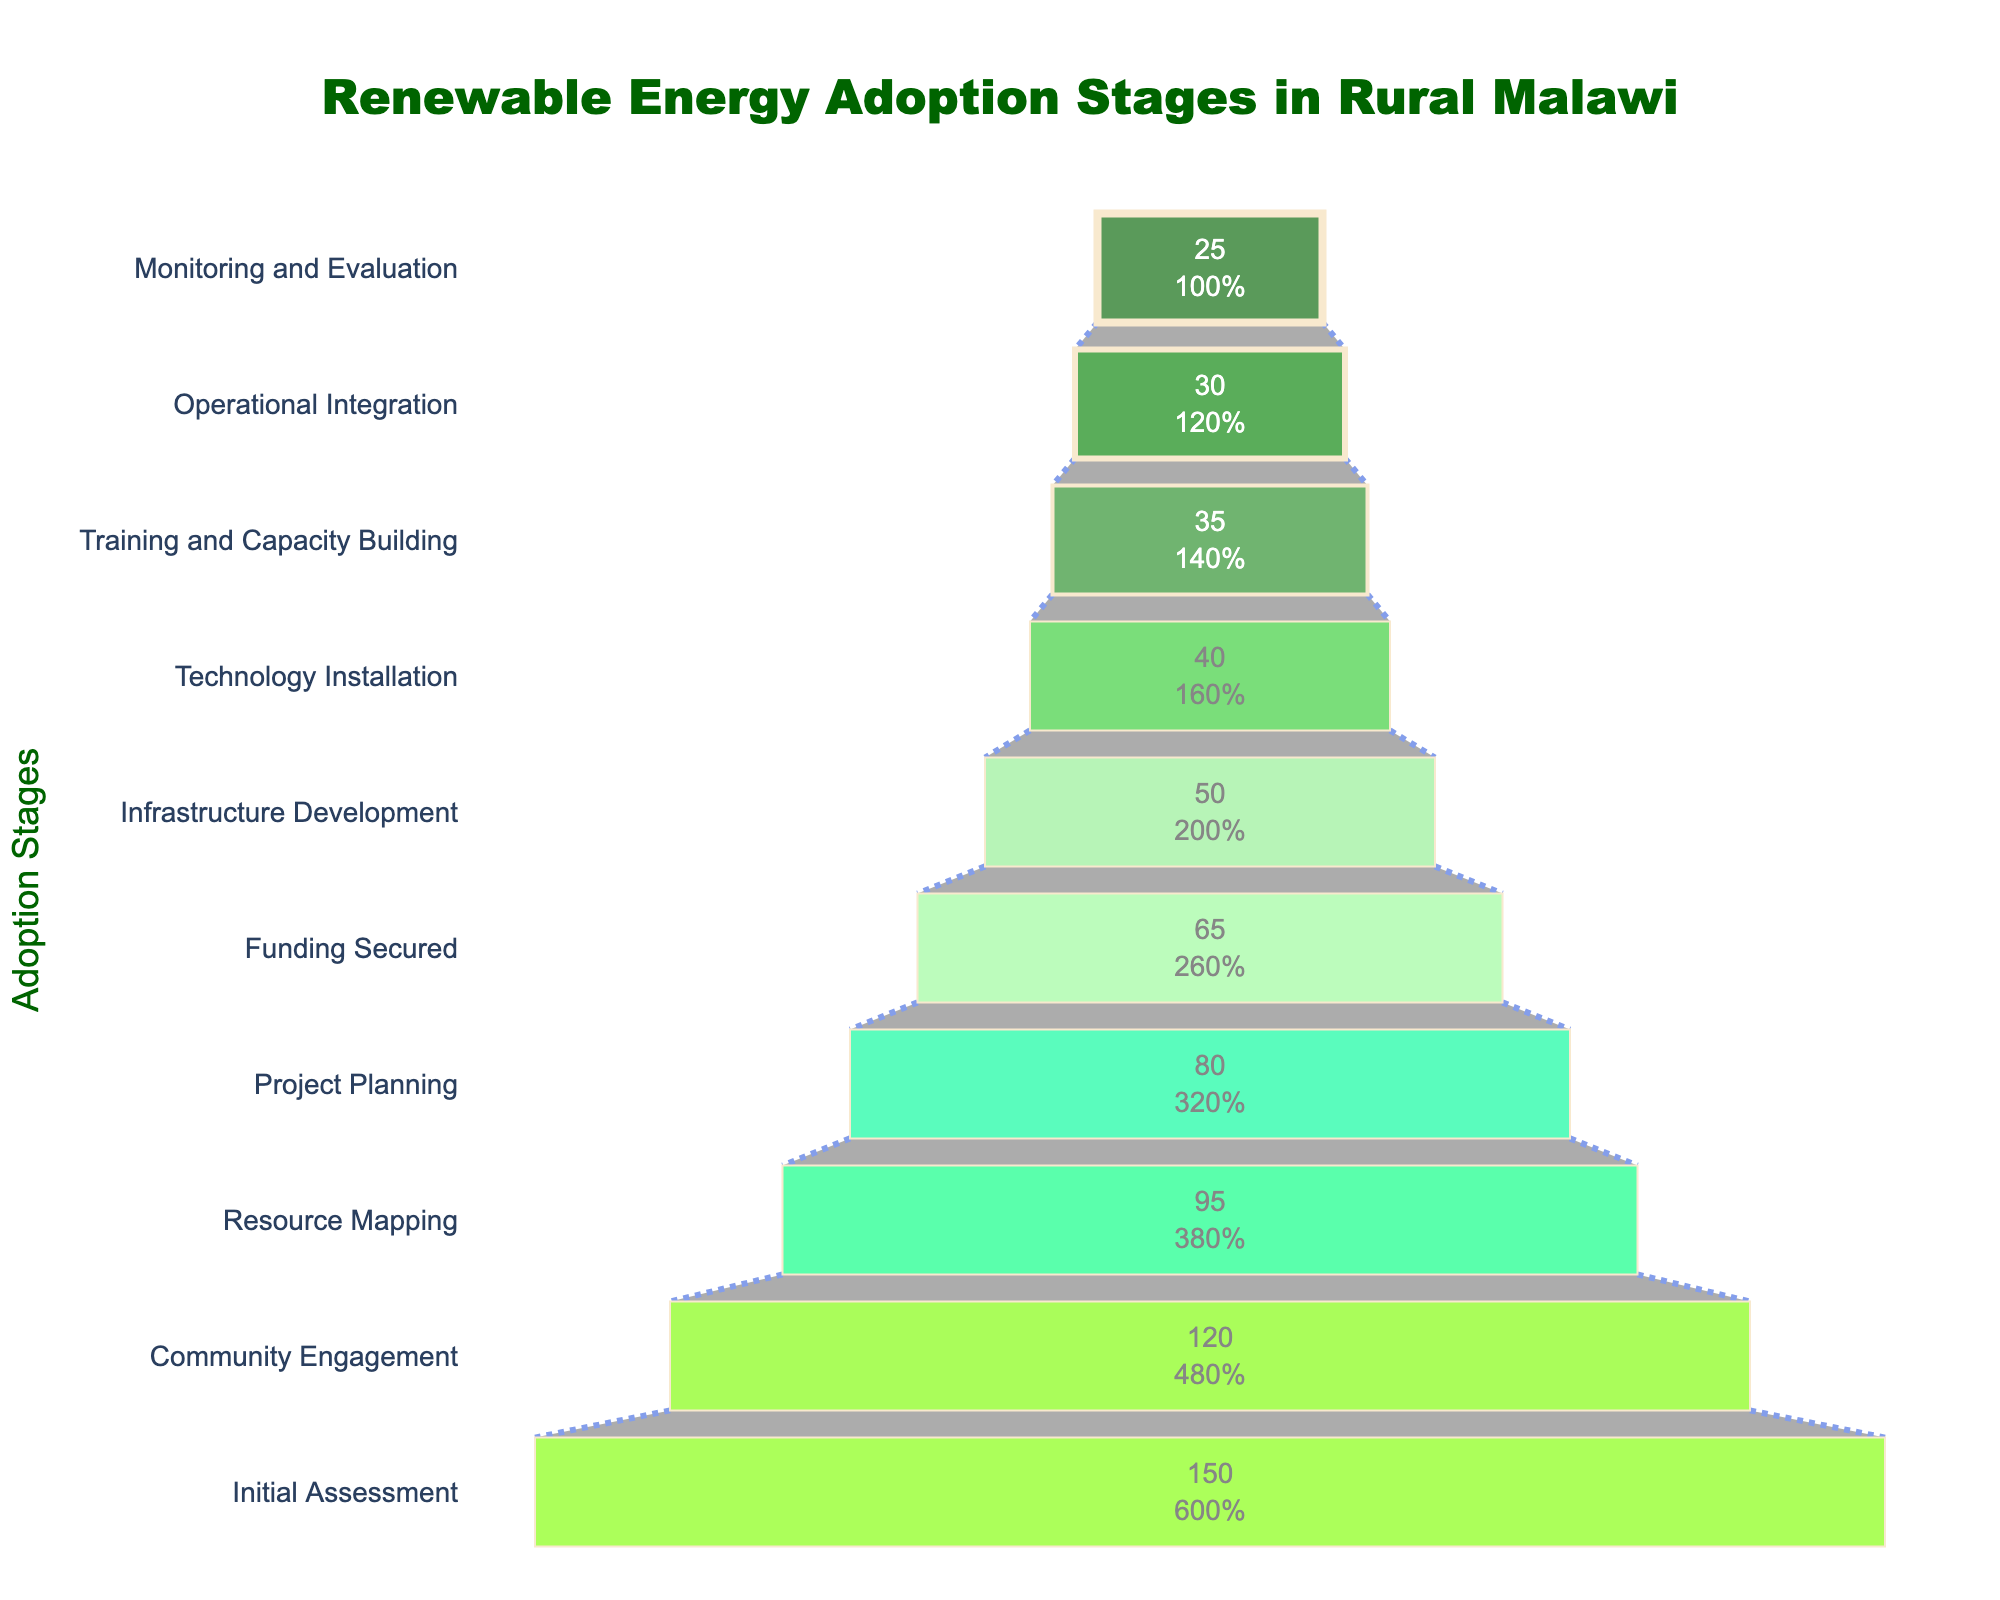What is the title of the funnel chart? The title is typically located at the top of the chart and summarizes the content or purpose of the chart.
Answer: Renewable Energy Adoption Stages in Rural Malawi How many stages are shown in the funnel chart? Count the unique stages listed on the y-axis of the chart.
Answer: 10 Which stage has the highest number of villages? The highest number of villages is represented by the widest bar at the top of the funnel. This corresponds to the first stage listed in the data.
Answer: Initial Assessment How many villages reach the 'Operational Integration' stage? Find the 'Operational Integration' stage on the y-axis and check the number of villages corresponding to that stage.
Answer: 30 What percentage of villages reach the 'Monitoring and Evaluation' stage compared to the initial stage? Divide the number of villages at 'Monitoring and Evaluation' by the number at 'Initial Assessment' and multiply by 100 to find the percentage. (25 / 150) * 100 = 16.67%.
Answer: 16.67% What is the difference in the number of villages between 'Funding Secured' and 'Training and Capacity Building' stages? Subtract the number of villages at the 'Training and Capacity Building' stage from the number at the 'Funding Secured' stage. 65 - 35 = 30.
Answer: 30 How many villages drop out between the 'Community Engagement' and 'Resource Mapping' stages? Subtract the number of villages at the 'Resource Mapping' stage from the number at the 'Community Engagement' stage. 120 - 95 = 25.
Answer: 25 What percentage of villages proceed from 'Community Engagement' to 'Resource Mapping'? Divide the number of villages at 'Resource Mapping' by the number at 'Community Engagement' and multiply by 100. (95 / 120) * 100 = 79.17%.
Answer: 79.17% In which stage does the largest drop in the number of villages occur? Calculate the difference in the number of villages for each consecutive stage and identify the stage pair with the maximum difference. The largest drop is between 'Community Engagement' and 'Resource Mapping' (120 - 95 = 25).
Answer: Between Community Engagement and Resource Mapping At which stages do fewer than half of the initial villages remain? Identify stages where the number of villages is less than half of 150 (which is 75). Stages include 'Funding Secured', 'Infrastructure Development', 'Technology Installation', 'Training and Capacity Building', 'Operational Integration', and 'Monitoring and Evaluation'.
Answer: Funding Secured, Infrastructure Development, Technology Installation, Training and Capacity Building, Operational Integration, Monitoring and Evaluation 